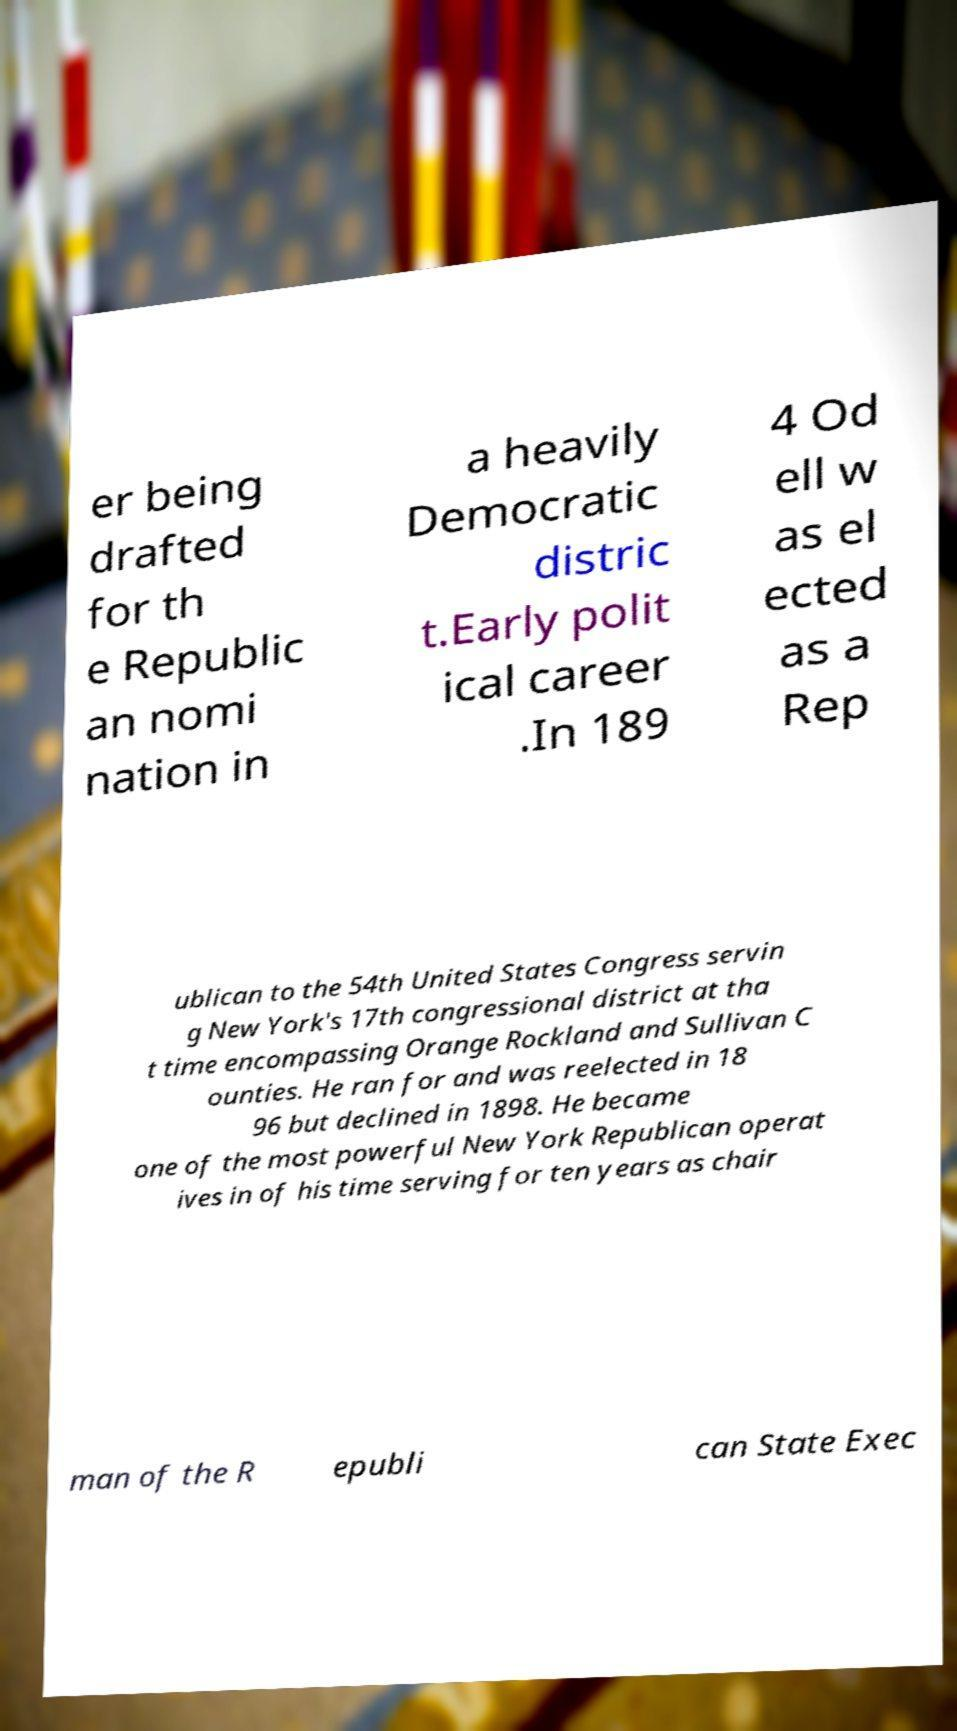Please read and relay the text visible in this image. What does it say? er being drafted for th e Republic an nomi nation in a heavily Democratic distric t.Early polit ical career .In 189 4 Od ell w as el ected as a Rep ublican to the 54th United States Congress servin g New York's 17th congressional district at tha t time encompassing Orange Rockland and Sullivan C ounties. He ran for and was reelected in 18 96 but declined in 1898. He became one of the most powerful New York Republican operat ives in of his time serving for ten years as chair man of the R epubli can State Exec 